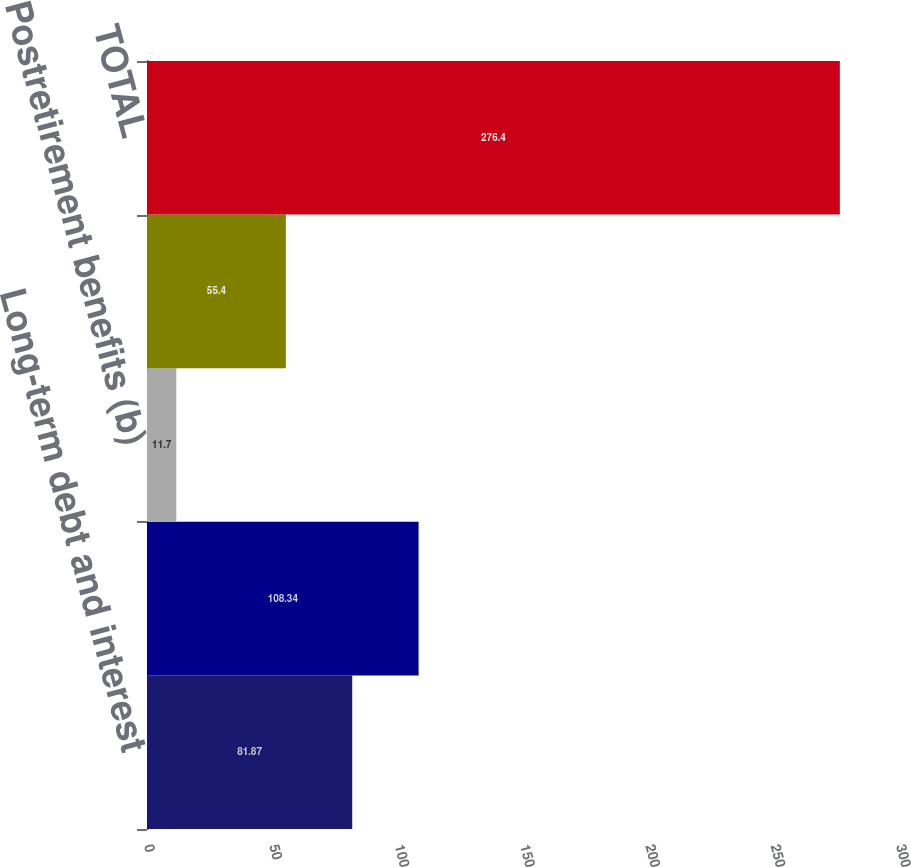Convert chart. <chart><loc_0><loc_0><loc_500><loc_500><bar_chart><fcel>Long-term debt and interest<fcel>Minimum operating lease<fcel>Postretirement benefits (b)<fcel>Purchase obligations (d)<fcel>TOTAL<nl><fcel>81.87<fcel>108.34<fcel>11.7<fcel>55.4<fcel>276.4<nl></chart> 